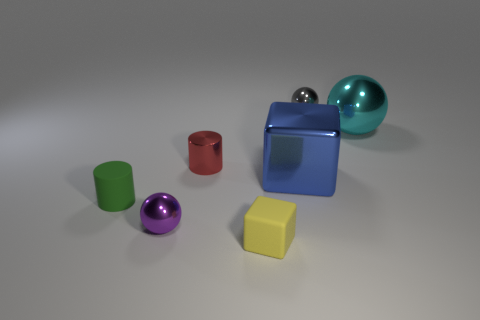How many balls are metal objects or tiny red metallic things?
Provide a succinct answer. 3. What color is the matte cylinder that is the same size as the purple object?
Offer a terse response. Green. What is the shape of the small green thing in front of the block that is behind the tiny purple metallic object?
Your answer should be very brief. Cylinder. Is the size of the cube that is in front of the metallic block the same as the tiny red thing?
Your response must be concise. Yes. How many other things are the same material as the big cyan sphere?
Your answer should be compact. 4. How many gray objects are either tiny matte cylinders or rubber things?
Keep it short and to the point. 0. There is a metal cylinder; what number of purple metal balls are right of it?
Give a very brief answer. 0. What size is the sphere left of the small cylinder that is on the right side of the sphere in front of the large blue cube?
Offer a very short reply. Small. There is a big metallic object to the left of the large object that is on the right side of the blue metallic block; is there a tiny gray metal thing on the left side of it?
Keep it short and to the point. No. Are there more tiny green cylinders than big cyan shiny cylinders?
Your answer should be compact. Yes. 